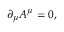<formula> <loc_0><loc_0><loc_500><loc_500>\partial _ { \mu } A ^ { \mu } = 0 ,</formula> 